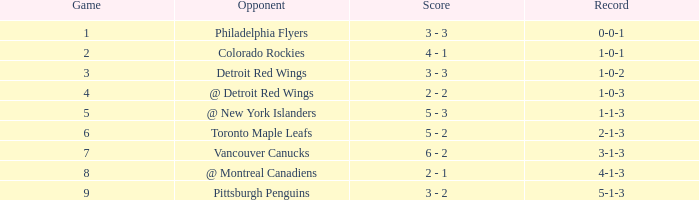Which game is considered the greatest in october and costs less than 1? None. 